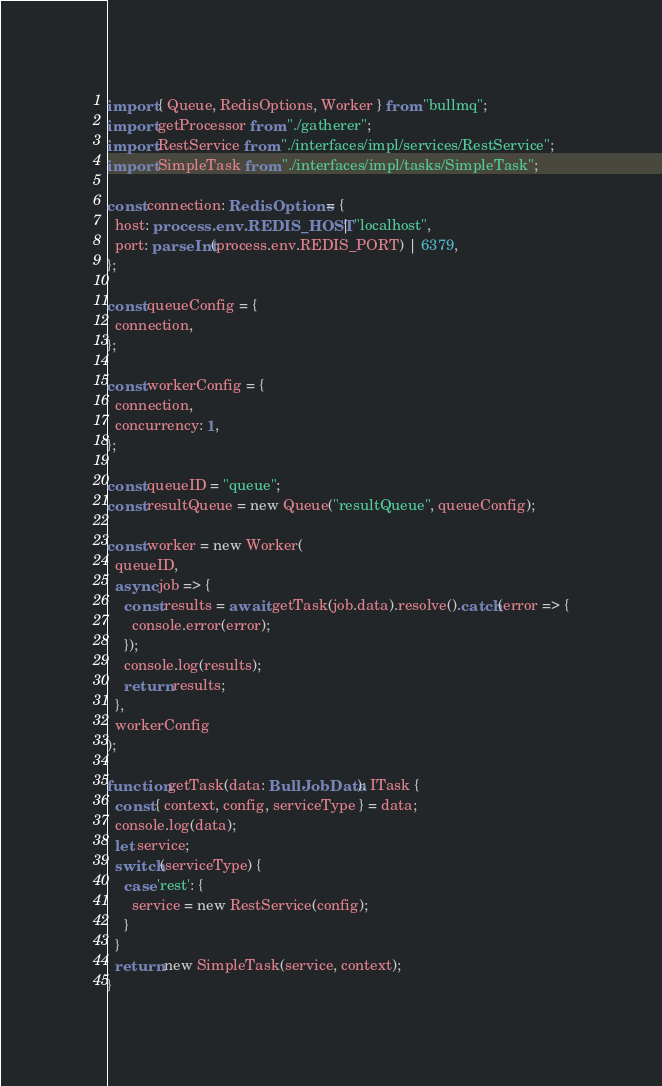Convert code to text. <code><loc_0><loc_0><loc_500><loc_500><_TypeScript_>import { Queue, RedisOptions, Worker } from "bullmq";
import getProcessor from "./gatherer";
import RestService from "./interfaces/impl/services/RestService";
import SimpleTask from "./interfaces/impl/tasks/SimpleTask";

const connection: RedisOptions = {
  host: process.env.REDIS_HOST | "localhost",
  port: parseInt(process.env.REDIS_PORT) | 6379,
};

const queueConfig = {
  connection,
};

const workerConfig = {
  connection,
  concurrency: 1,
};

const queueID = "queue";
const resultQueue = new Queue("resultQueue", queueConfig);

const worker = new Worker(
  queueID,
  async job => {
    const results = await getTask(job.data).resolve().catch(error => {
      console.error(error);
    });
    console.log(results);
    return results;
  },
  workerConfig
);

function getTask(data: BullJobData): ITask {
  const { context, config, serviceType } = data;
  console.log(data);
  let service;
  switch(serviceType) {
    case 'rest': {
      service = new RestService(config);
    }
  }
  return new SimpleTask(service, context);
}
</code> 